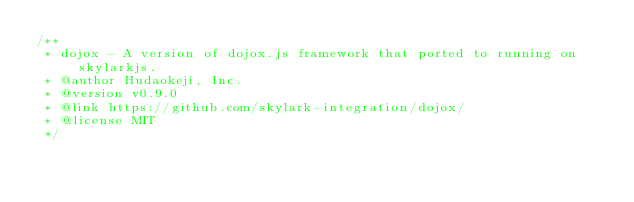Convert code to text. <code><loc_0><loc_0><loc_500><loc_500><_JavaScript_>/**
 * dojox - A version of dojox.js framework that ported to running on skylarkjs.
 * @author Hudaokeji, Inc.
 * @version v0.9.0
 * @link https://github.com/skylark-integration/dojox/
 * @license MIT
 */</code> 